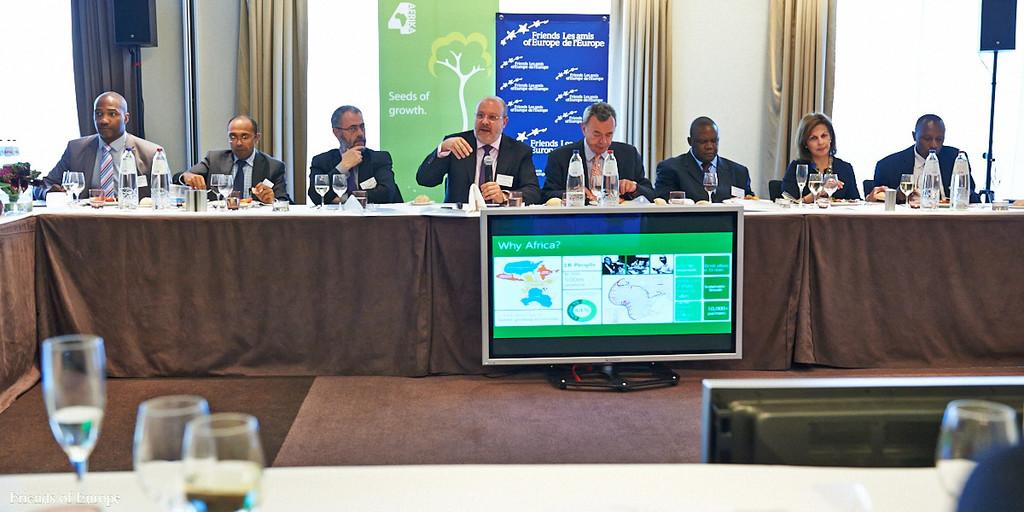Provide a one-sentence caption for the provided image. Large computer monitor that says "Why Africa?" in front of a group of people having a meeting. 